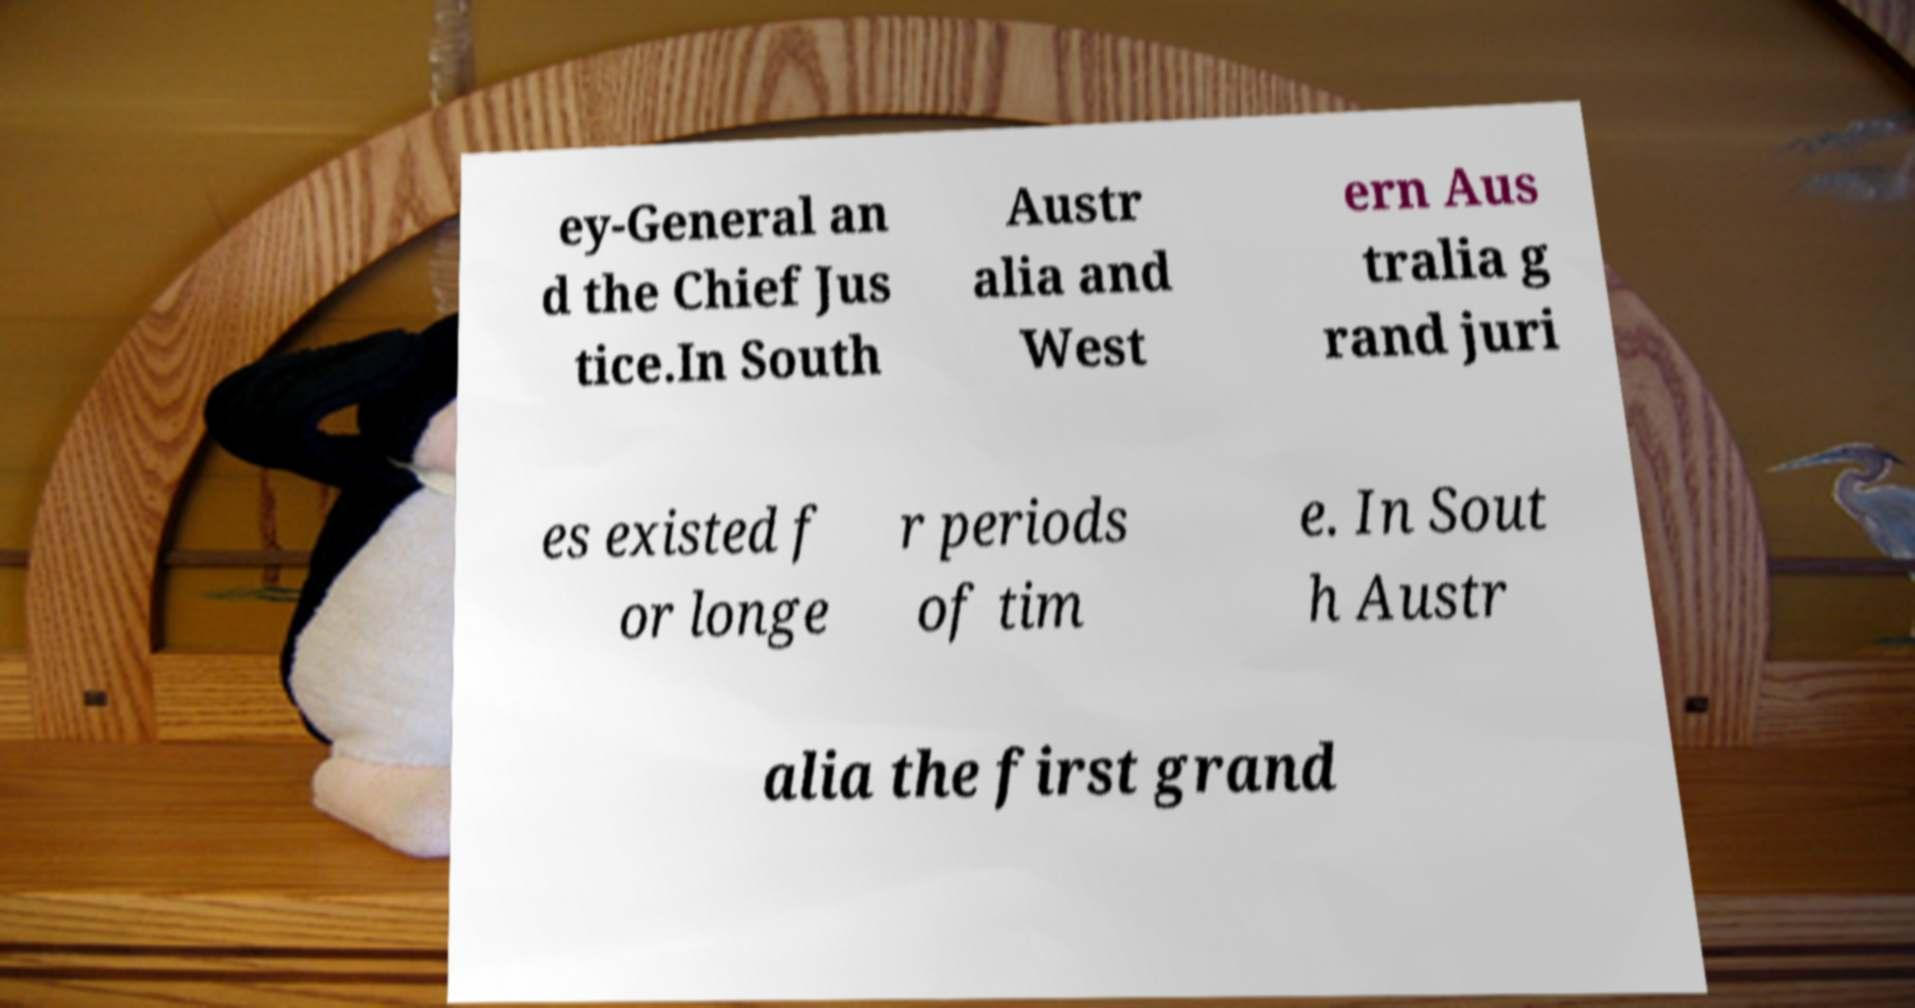Can you accurately transcribe the text from the provided image for me? ey-General an d the Chief Jus tice.In South Austr alia and West ern Aus tralia g rand juri es existed f or longe r periods of tim e. In Sout h Austr alia the first grand 